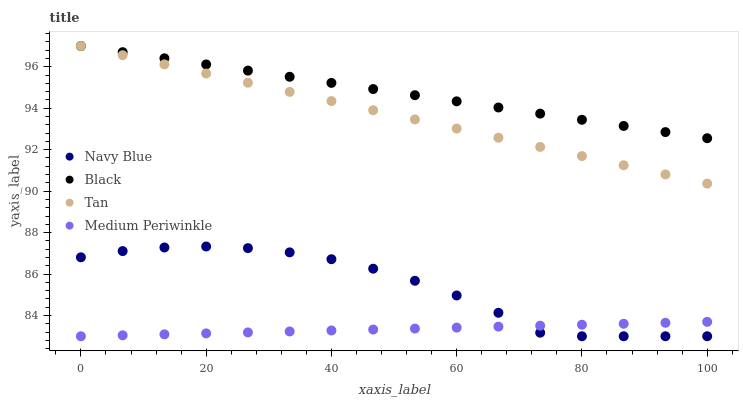Does Medium Periwinkle have the minimum area under the curve?
Answer yes or no. Yes. Does Black have the maximum area under the curve?
Answer yes or no. Yes. Does Tan have the minimum area under the curve?
Answer yes or no. No. Does Tan have the maximum area under the curve?
Answer yes or no. No. Is Black the smoothest?
Answer yes or no. Yes. Is Navy Blue the roughest?
Answer yes or no. Yes. Is Tan the smoothest?
Answer yes or no. No. Is Tan the roughest?
Answer yes or no. No. Does Navy Blue have the lowest value?
Answer yes or no. Yes. Does Tan have the lowest value?
Answer yes or no. No. Does Black have the highest value?
Answer yes or no. Yes. Does Medium Periwinkle have the highest value?
Answer yes or no. No. Is Medium Periwinkle less than Tan?
Answer yes or no. Yes. Is Black greater than Navy Blue?
Answer yes or no. Yes. Does Black intersect Tan?
Answer yes or no. Yes. Is Black less than Tan?
Answer yes or no. No. Is Black greater than Tan?
Answer yes or no. No. Does Medium Periwinkle intersect Tan?
Answer yes or no. No. 